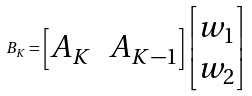<formula> <loc_0><loc_0><loc_500><loc_500>B _ { K } = \begin{bmatrix} A _ { K } & A _ { K - 1 } \end{bmatrix} \begin{bmatrix} w _ { 1 } \\ w _ { 2 } \end{bmatrix}</formula> 